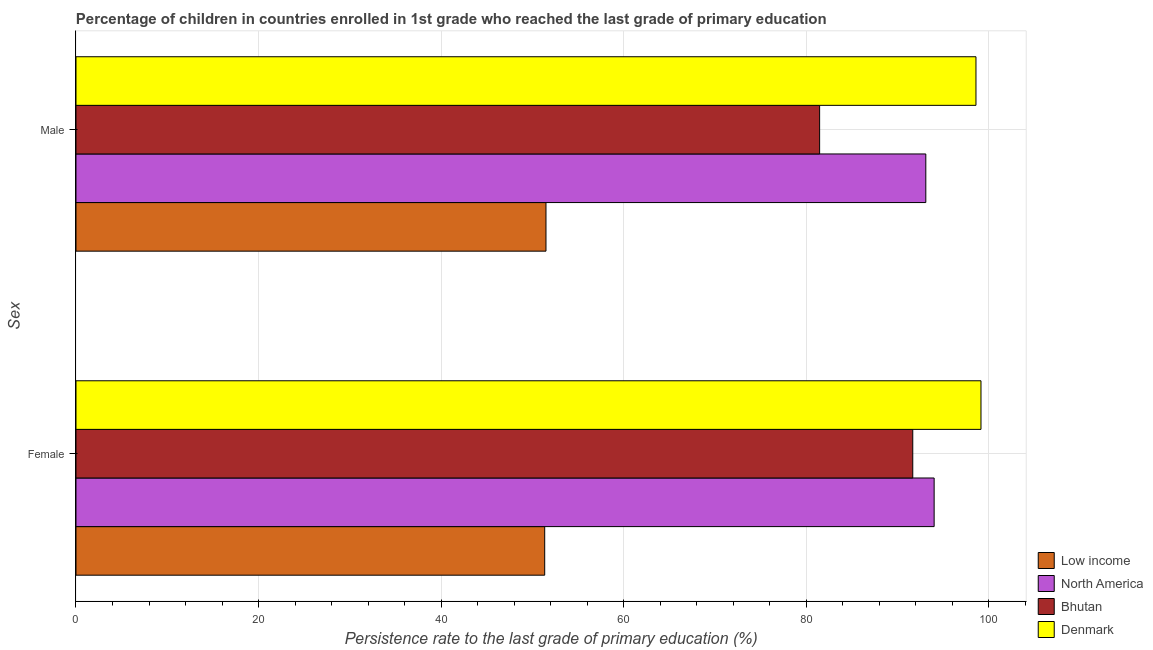How many different coloured bars are there?
Your response must be concise. 4. How many groups of bars are there?
Keep it short and to the point. 2. Are the number of bars per tick equal to the number of legend labels?
Your response must be concise. Yes. How many bars are there on the 2nd tick from the top?
Your answer should be very brief. 4. What is the label of the 2nd group of bars from the top?
Provide a short and direct response. Female. What is the persistence rate of female students in North America?
Provide a succinct answer. 94.04. Across all countries, what is the maximum persistence rate of female students?
Your response must be concise. 99.17. Across all countries, what is the minimum persistence rate of female students?
Give a very brief answer. 51.36. In which country was the persistence rate of male students minimum?
Your response must be concise. Low income. What is the total persistence rate of male students in the graph?
Make the answer very short. 324.73. What is the difference between the persistence rate of female students in North America and that in Low income?
Your answer should be compact. 42.68. What is the difference between the persistence rate of female students in Bhutan and the persistence rate of male students in North America?
Provide a short and direct response. -1.43. What is the average persistence rate of male students per country?
Provide a short and direct response. 81.18. What is the difference between the persistence rate of male students and persistence rate of female students in Bhutan?
Your answer should be compact. -10.21. What is the ratio of the persistence rate of male students in Denmark to that in Low income?
Make the answer very short. 1.91. Is the persistence rate of female students in Bhutan less than that in Denmark?
Ensure brevity in your answer.  Yes. In how many countries, is the persistence rate of male students greater than the average persistence rate of male students taken over all countries?
Give a very brief answer. 3. What does the 2nd bar from the top in Female represents?
Make the answer very short. Bhutan. What does the 1st bar from the bottom in Female represents?
Your answer should be compact. Low income. How many bars are there?
Your answer should be very brief. 8. Are all the bars in the graph horizontal?
Give a very brief answer. Yes. How many countries are there in the graph?
Ensure brevity in your answer.  4. What is the difference between two consecutive major ticks on the X-axis?
Your answer should be very brief. 20. Are the values on the major ticks of X-axis written in scientific E-notation?
Offer a terse response. No. Does the graph contain any zero values?
Keep it short and to the point. No. How are the legend labels stacked?
Provide a short and direct response. Vertical. What is the title of the graph?
Give a very brief answer. Percentage of children in countries enrolled in 1st grade who reached the last grade of primary education. Does "Hong Kong" appear as one of the legend labels in the graph?
Offer a terse response. No. What is the label or title of the X-axis?
Your answer should be very brief. Persistence rate to the last grade of primary education (%). What is the label or title of the Y-axis?
Make the answer very short. Sex. What is the Persistence rate to the last grade of primary education (%) of Low income in Female?
Provide a short and direct response. 51.36. What is the Persistence rate to the last grade of primary education (%) of North America in Female?
Offer a very short reply. 94.04. What is the Persistence rate to the last grade of primary education (%) of Bhutan in Female?
Offer a terse response. 91.69. What is the Persistence rate to the last grade of primary education (%) in Denmark in Female?
Keep it short and to the point. 99.17. What is the Persistence rate to the last grade of primary education (%) of Low income in Male?
Ensure brevity in your answer.  51.5. What is the Persistence rate to the last grade of primary education (%) of North America in Male?
Keep it short and to the point. 93.12. What is the Persistence rate to the last grade of primary education (%) of Bhutan in Male?
Your answer should be very brief. 81.49. What is the Persistence rate to the last grade of primary education (%) in Denmark in Male?
Keep it short and to the point. 98.62. Across all Sex, what is the maximum Persistence rate to the last grade of primary education (%) in Low income?
Your answer should be very brief. 51.5. Across all Sex, what is the maximum Persistence rate to the last grade of primary education (%) in North America?
Offer a very short reply. 94.04. Across all Sex, what is the maximum Persistence rate to the last grade of primary education (%) of Bhutan?
Give a very brief answer. 91.69. Across all Sex, what is the maximum Persistence rate to the last grade of primary education (%) in Denmark?
Your answer should be compact. 99.17. Across all Sex, what is the minimum Persistence rate to the last grade of primary education (%) of Low income?
Ensure brevity in your answer.  51.36. Across all Sex, what is the minimum Persistence rate to the last grade of primary education (%) in North America?
Your response must be concise. 93.12. Across all Sex, what is the minimum Persistence rate to the last grade of primary education (%) in Bhutan?
Your response must be concise. 81.49. Across all Sex, what is the minimum Persistence rate to the last grade of primary education (%) in Denmark?
Your response must be concise. 98.62. What is the total Persistence rate to the last grade of primary education (%) of Low income in the graph?
Give a very brief answer. 102.86. What is the total Persistence rate to the last grade of primary education (%) of North America in the graph?
Make the answer very short. 187.16. What is the total Persistence rate to the last grade of primary education (%) of Bhutan in the graph?
Offer a very short reply. 173.18. What is the total Persistence rate to the last grade of primary education (%) in Denmark in the graph?
Your response must be concise. 197.79. What is the difference between the Persistence rate to the last grade of primary education (%) in Low income in Female and that in Male?
Offer a terse response. -0.14. What is the difference between the Persistence rate to the last grade of primary education (%) of North America in Female and that in Male?
Your response must be concise. 0.91. What is the difference between the Persistence rate to the last grade of primary education (%) in Bhutan in Female and that in Male?
Make the answer very short. 10.21. What is the difference between the Persistence rate to the last grade of primary education (%) in Denmark in Female and that in Male?
Your response must be concise. 0.55. What is the difference between the Persistence rate to the last grade of primary education (%) in Low income in Female and the Persistence rate to the last grade of primary education (%) in North America in Male?
Make the answer very short. -41.76. What is the difference between the Persistence rate to the last grade of primary education (%) in Low income in Female and the Persistence rate to the last grade of primary education (%) in Bhutan in Male?
Provide a succinct answer. -30.13. What is the difference between the Persistence rate to the last grade of primary education (%) of Low income in Female and the Persistence rate to the last grade of primary education (%) of Denmark in Male?
Offer a terse response. -47.26. What is the difference between the Persistence rate to the last grade of primary education (%) in North America in Female and the Persistence rate to the last grade of primary education (%) in Bhutan in Male?
Give a very brief answer. 12.55. What is the difference between the Persistence rate to the last grade of primary education (%) in North America in Female and the Persistence rate to the last grade of primary education (%) in Denmark in Male?
Your answer should be compact. -4.58. What is the difference between the Persistence rate to the last grade of primary education (%) in Bhutan in Female and the Persistence rate to the last grade of primary education (%) in Denmark in Male?
Ensure brevity in your answer.  -6.93. What is the average Persistence rate to the last grade of primary education (%) of Low income per Sex?
Your answer should be very brief. 51.43. What is the average Persistence rate to the last grade of primary education (%) of North America per Sex?
Give a very brief answer. 93.58. What is the average Persistence rate to the last grade of primary education (%) in Bhutan per Sex?
Keep it short and to the point. 86.59. What is the average Persistence rate to the last grade of primary education (%) of Denmark per Sex?
Make the answer very short. 98.89. What is the difference between the Persistence rate to the last grade of primary education (%) in Low income and Persistence rate to the last grade of primary education (%) in North America in Female?
Offer a terse response. -42.68. What is the difference between the Persistence rate to the last grade of primary education (%) of Low income and Persistence rate to the last grade of primary education (%) of Bhutan in Female?
Keep it short and to the point. -40.33. What is the difference between the Persistence rate to the last grade of primary education (%) of Low income and Persistence rate to the last grade of primary education (%) of Denmark in Female?
Give a very brief answer. -47.81. What is the difference between the Persistence rate to the last grade of primary education (%) of North America and Persistence rate to the last grade of primary education (%) of Bhutan in Female?
Make the answer very short. 2.34. What is the difference between the Persistence rate to the last grade of primary education (%) of North America and Persistence rate to the last grade of primary education (%) of Denmark in Female?
Your response must be concise. -5.13. What is the difference between the Persistence rate to the last grade of primary education (%) in Bhutan and Persistence rate to the last grade of primary education (%) in Denmark in Female?
Offer a very short reply. -7.47. What is the difference between the Persistence rate to the last grade of primary education (%) of Low income and Persistence rate to the last grade of primary education (%) of North America in Male?
Ensure brevity in your answer.  -41.62. What is the difference between the Persistence rate to the last grade of primary education (%) of Low income and Persistence rate to the last grade of primary education (%) of Bhutan in Male?
Give a very brief answer. -29.99. What is the difference between the Persistence rate to the last grade of primary education (%) of Low income and Persistence rate to the last grade of primary education (%) of Denmark in Male?
Make the answer very short. -47.12. What is the difference between the Persistence rate to the last grade of primary education (%) of North America and Persistence rate to the last grade of primary education (%) of Bhutan in Male?
Your answer should be very brief. 11.63. What is the difference between the Persistence rate to the last grade of primary education (%) of North America and Persistence rate to the last grade of primary education (%) of Denmark in Male?
Your answer should be compact. -5.5. What is the difference between the Persistence rate to the last grade of primary education (%) in Bhutan and Persistence rate to the last grade of primary education (%) in Denmark in Male?
Provide a succinct answer. -17.13. What is the ratio of the Persistence rate to the last grade of primary education (%) of Low income in Female to that in Male?
Give a very brief answer. 1. What is the ratio of the Persistence rate to the last grade of primary education (%) of North America in Female to that in Male?
Your answer should be very brief. 1.01. What is the ratio of the Persistence rate to the last grade of primary education (%) in Bhutan in Female to that in Male?
Your answer should be very brief. 1.13. What is the ratio of the Persistence rate to the last grade of primary education (%) of Denmark in Female to that in Male?
Provide a succinct answer. 1.01. What is the difference between the highest and the second highest Persistence rate to the last grade of primary education (%) in Low income?
Offer a terse response. 0.14. What is the difference between the highest and the second highest Persistence rate to the last grade of primary education (%) in North America?
Make the answer very short. 0.91. What is the difference between the highest and the second highest Persistence rate to the last grade of primary education (%) of Bhutan?
Provide a short and direct response. 10.21. What is the difference between the highest and the second highest Persistence rate to the last grade of primary education (%) in Denmark?
Your response must be concise. 0.55. What is the difference between the highest and the lowest Persistence rate to the last grade of primary education (%) in Low income?
Provide a succinct answer. 0.14. What is the difference between the highest and the lowest Persistence rate to the last grade of primary education (%) in North America?
Give a very brief answer. 0.91. What is the difference between the highest and the lowest Persistence rate to the last grade of primary education (%) of Bhutan?
Your answer should be compact. 10.21. What is the difference between the highest and the lowest Persistence rate to the last grade of primary education (%) of Denmark?
Make the answer very short. 0.55. 